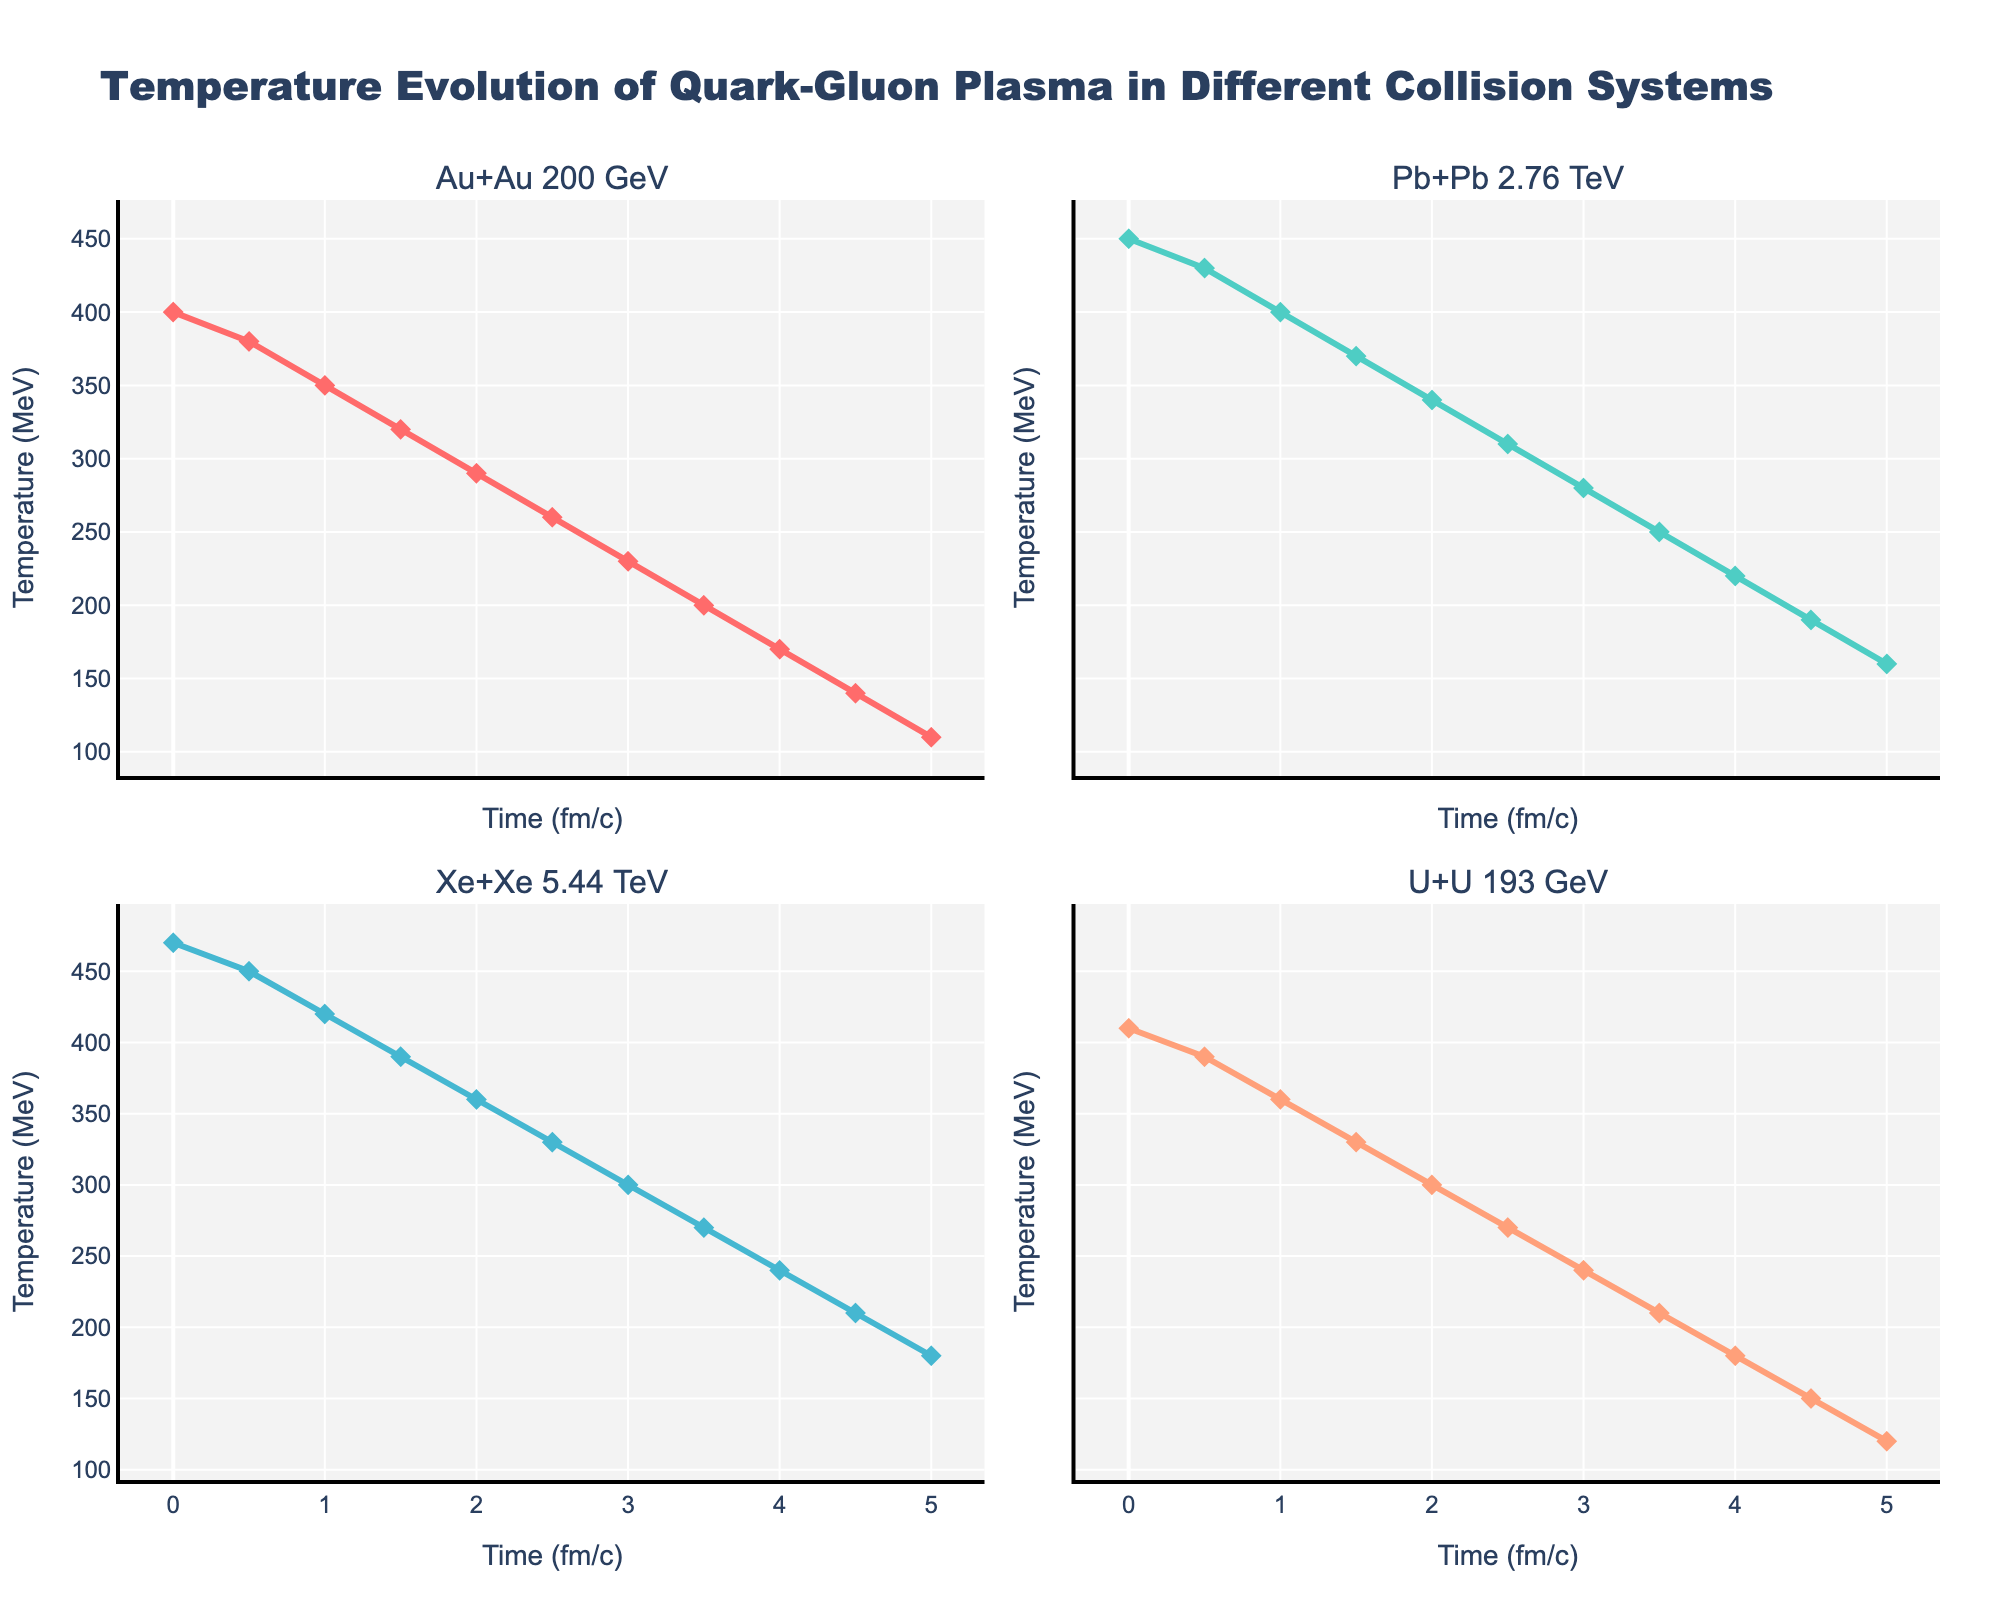what is the title of the figure? The title is usually displayed at the top of the figure. In this case, it is "Temperature Evolution of Quark-Gluon Plasma in Different Collision Systems" located at the top center of the figure.
Answer: Temperature Evolution of Quark-Gluon Plasma in Different Collision Systems What does the y-axis represent? The y-axis represents temperature values, and its unit is MeV (Mega Electron Volts). You can tell this by looking at the y-axis label which reads "Temperature (MeV)".
Answer: Temperature (MeV) Which collision system shows the highest initial temperature? By examining the starting point at Time = 0 on each subplot, you can see that the Xe+Xe 5.44 TeV collision system has the highest initial temperature of 470 MeV.
Answer: Xe+Xe 5.44 TeV At what time does the temperature of the U+U 193 GeV system drop below 300 MeV? You need to look at the U+U 193 GeV subplot and find the time value where the temperature drops below 300 MeV. This first occurs at 2.5 fm/c.
Answer: 2.5 fm/c Compare the temperature at 1 fm/c across all collision systems. Which is the highest and which is the lowest? At 1 fm/c, the temperatures are as follows: Au+Au 200 GeV - 350 MeV, Pb+Pb 2.76 TeV - 400 MeV, Xe+Xe 5.44 TeV - 420 MeV, and U+U 193 GeV - 360 MeV. The highest is Xe+Xe 5.44 TeV at 420 MeV and the lowest is Au+Au 200 GeV at 350 MeV.
Answer: Highest: Xe+Xe 5.44 TeV, Lowest: Au+Au 200 GeV How does the temperature of the Pb+Pb 2.76 TeV system change from 0 fm/c to 5 fm/c? The temperature declines gradually from 450 MeV at 0 fm/c to 160 MeV at 5 fm/c. This shows a consistent cooling trend over time.
Answer: Gradually declines from 450 MeV to 160 MeV Which collision system experiences the steepest temperature drop between 0 and 0.5 fm/c? You need to calculate the difference in temperature between 0 and 0.5 fm/c for all systems: 
Au+Au 200 GeV: 400 - 380 = 20 MeV,
Pb+Pb 2.76 TeV: 450 - 430 = 20 MeV,
Xe+Xe 5.44 TeV: 470 - 450 = 20 MeV,
U+U 193 GeV: 410 - 390 = 20 MeV.
All systems experience an equal drop of 20 MeV.
Answer: All systems What is the average temperature of the Au+Au 200 GeV system between 2 fm/c and 4 fm/c? Calculate the average of the temperatures at 2, 2.5, 3, 3.5, and 4 fm/c: (290 + 260 + 230 + 200 + 170) / 5 = 1150 / 5 = 230 MeV
Answer: 230 MeV Between 4 and 5 fm/c in the Pb+Pb 2.76 TeV system, what is the rate of temperature change per fm/c? Calculate the difference in temperature between 4 and 5 fm/c and then divide by the time difference (1 fm/c):
(190 - 160) / 1 = 30 MeV/fm/c
Answer: 30 MeV/fm/c 